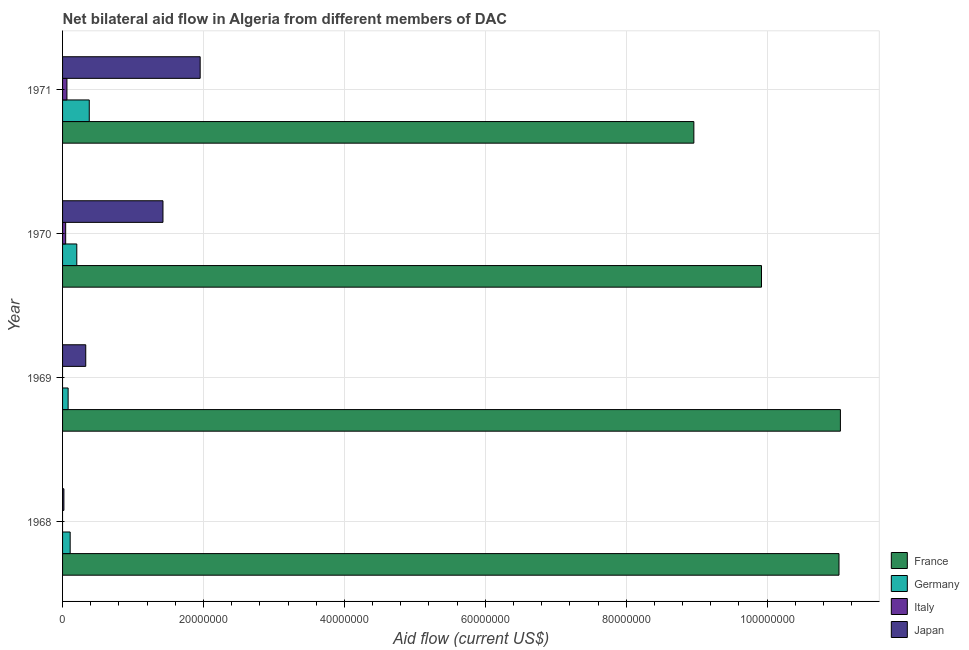How many different coloured bars are there?
Provide a short and direct response. 4. Are the number of bars on each tick of the Y-axis equal?
Offer a very short reply. No. How many bars are there on the 4th tick from the top?
Make the answer very short. 3. How many bars are there on the 1st tick from the bottom?
Provide a short and direct response. 3. What is the label of the 1st group of bars from the top?
Make the answer very short. 1971. In how many cases, is the number of bars for a given year not equal to the number of legend labels?
Provide a short and direct response. 2. What is the amount of aid given by japan in 1969?
Offer a very short reply. 3.29e+06. Across all years, what is the maximum amount of aid given by japan?
Offer a very short reply. 1.95e+07. Across all years, what is the minimum amount of aid given by france?
Provide a short and direct response. 8.96e+07. In which year was the amount of aid given by italy maximum?
Your answer should be compact. 1971. What is the total amount of aid given by germany in the graph?
Provide a short and direct response. 7.68e+06. What is the difference between the amount of aid given by germany in 1969 and that in 1971?
Keep it short and to the point. -3.00e+06. What is the difference between the amount of aid given by italy in 1969 and the amount of aid given by germany in 1971?
Your answer should be very brief. -3.79e+06. What is the average amount of aid given by italy per year?
Offer a very short reply. 2.65e+05. In the year 1971, what is the difference between the amount of aid given by japan and amount of aid given by germany?
Ensure brevity in your answer.  1.57e+07. In how many years, is the amount of aid given by japan greater than 28000000 US$?
Your response must be concise. 0. What is the ratio of the amount of aid given by japan in 1968 to that in 1969?
Your response must be concise. 0.06. Is the difference between the amount of aid given by france in 1970 and 1971 greater than the difference between the amount of aid given by japan in 1970 and 1971?
Make the answer very short. Yes. What is the difference between the highest and the second highest amount of aid given by germany?
Give a very brief answer. 1.77e+06. What is the difference between the highest and the lowest amount of aid given by france?
Offer a terse response. 2.08e+07. In how many years, is the amount of aid given by japan greater than the average amount of aid given by japan taken over all years?
Offer a terse response. 2. Is it the case that in every year, the sum of the amount of aid given by italy and amount of aid given by germany is greater than the sum of amount of aid given by france and amount of aid given by japan?
Provide a short and direct response. No. Are all the bars in the graph horizontal?
Ensure brevity in your answer.  Yes. How many years are there in the graph?
Offer a very short reply. 4. Does the graph contain any zero values?
Your response must be concise. Yes. Where does the legend appear in the graph?
Offer a very short reply. Bottom right. How many legend labels are there?
Your response must be concise. 4. What is the title of the graph?
Provide a short and direct response. Net bilateral aid flow in Algeria from different members of DAC. Does "Insurance services" appear as one of the legend labels in the graph?
Ensure brevity in your answer.  No. What is the label or title of the X-axis?
Offer a terse response. Aid flow (current US$). What is the label or title of the Y-axis?
Ensure brevity in your answer.  Year. What is the Aid flow (current US$) of France in 1968?
Offer a terse response. 1.10e+08. What is the Aid flow (current US$) of Germany in 1968?
Offer a terse response. 1.08e+06. What is the Aid flow (current US$) of France in 1969?
Your response must be concise. 1.10e+08. What is the Aid flow (current US$) of Germany in 1969?
Give a very brief answer. 7.90e+05. What is the Aid flow (current US$) of Japan in 1969?
Give a very brief answer. 3.29e+06. What is the Aid flow (current US$) of France in 1970?
Provide a succinct answer. 9.92e+07. What is the Aid flow (current US$) of Germany in 1970?
Your response must be concise. 2.02e+06. What is the Aid flow (current US$) of Italy in 1970?
Ensure brevity in your answer.  4.40e+05. What is the Aid flow (current US$) in Japan in 1970?
Provide a short and direct response. 1.42e+07. What is the Aid flow (current US$) in France in 1971?
Offer a terse response. 8.96e+07. What is the Aid flow (current US$) of Germany in 1971?
Offer a terse response. 3.79e+06. What is the Aid flow (current US$) of Italy in 1971?
Keep it short and to the point. 6.20e+05. What is the Aid flow (current US$) of Japan in 1971?
Your answer should be very brief. 1.95e+07. Across all years, what is the maximum Aid flow (current US$) in France?
Give a very brief answer. 1.10e+08. Across all years, what is the maximum Aid flow (current US$) in Germany?
Provide a short and direct response. 3.79e+06. Across all years, what is the maximum Aid flow (current US$) in Italy?
Your response must be concise. 6.20e+05. Across all years, what is the maximum Aid flow (current US$) of Japan?
Provide a short and direct response. 1.95e+07. Across all years, what is the minimum Aid flow (current US$) of France?
Give a very brief answer. 8.96e+07. Across all years, what is the minimum Aid flow (current US$) in Germany?
Your response must be concise. 7.90e+05. Across all years, what is the minimum Aid flow (current US$) of Italy?
Ensure brevity in your answer.  0. Across all years, what is the minimum Aid flow (current US$) of Japan?
Offer a terse response. 1.90e+05. What is the total Aid flow (current US$) of France in the graph?
Provide a succinct answer. 4.09e+08. What is the total Aid flow (current US$) in Germany in the graph?
Offer a terse response. 7.68e+06. What is the total Aid flow (current US$) in Italy in the graph?
Your answer should be compact. 1.06e+06. What is the total Aid flow (current US$) of Japan in the graph?
Provide a short and direct response. 3.73e+07. What is the difference between the Aid flow (current US$) in France in 1968 and that in 1969?
Provide a succinct answer. -2.00e+05. What is the difference between the Aid flow (current US$) in Germany in 1968 and that in 1969?
Keep it short and to the point. 2.90e+05. What is the difference between the Aid flow (current US$) in Japan in 1968 and that in 1969?
Provide a succinct answer. -3.10e+06. What is the difference between the Aid flow (current US$) in France in 1968 and that in 1970?
Your answer should be very brief. 1.10e+07. What is the difference between the Aid flow (current US$) in Germany in 1968 and that in 1970?
Provide a succinct answer. -9.40e+05. What is the difference between the Aid flow (current US$) in Japan in 1968 and that in 1970?
Keep it short and to the point. -1.41e+07. What is the difference between the Aid flow (current US$) of France in 1968 and that in 1971?
Your answer should be very brief. 2.06e+07. What is the difference between the Aid flow (current US$) of Germany in 1968 and that in 1971?
Your response must be concise. -2.71e+06. What is the difference between the Aid flow (current US$) of Japan in 1968 and that in 1971?
Your response must be concise. -1.93e+07. What is the difference between the Aid flow (current US$) in France in 1969 and that in 1970?
Your answer should be very brief. 1.12e+07. What is the difference between the Aid flow (current US$) in Germany in 1969 and that in 1970?
Give a very brief answer. -1.23e+06. What is the difference between the Aid flow (current US$) in Japan in 1969 and that in 1970?
Provide a short and direct response. -1.10e+07. What is the difference between the Aid flow (current US$) in France in 1969 and that in 1971?
Provide a short and direct response. 2.08e+07. What is the difference between the Aid flow (current US$) in Germany in 1969 and that in 1971?
Provide a short and direct response. -3.00e+06. What is the difference between the Aid flow (current US$) in Japan in 1969 and that in 1971?
Keep it short and to the point. -1.62e+07. What is the difference between the Aid flow (current US$) of France in 1970 and that in 1971?
Keep it short and to the point. 9.60e+06. What is the difference between the Aid flow (current US$) in Germany in 1970 and that in 1971?
Make the answer very short. -1.77e+06. What is the difference between the Aid flow (current US$) in Japan in 1970 and that in 1971?
Ensure brevity in your answer.  -5.28e+06. What is the difference between the Aid flow (current US$) of France in 1968 and the Aid flow (current US$) of Germany in 1969?
Provide a short and direct response. 1.09e+08. What is the difference between the Aid flow (current US$) of France in 1968 and the Aid flow (current US$) of Japan in 1969?
Provide a short and direct response. 1.07e+08. What is the difference between the Aid flow (current US$) of Germany in 1968 and the Aid flow (current US$) of Japan in 1969?
Keep it short and to the point. -2.21e+06. What is the difference between the Aid flow (current US$) of France in 1968 and the Aid flow (current US$) of Germany in 1970?
Your answer should be very brief. 1.08e+08. What is the difference between the Aid flow (current US$) in France in 1968 and the Aid flow (current US$) in Italy in 1970?
Provide a short and direct response. 1.10e+08. What is the difference between the Aid flow (current US$) in France in 1968 and the Aid flow (current US$) in Japan in 1970?
Offer a very short reply. 9.60e+07. What is the difference between the Aid flow (current US$) of Germany in 1968 and the Aid flow (current US$) of Italy in 1970?
Provide a short and direct response. 6.40e+05. What is the difference between the Aid flow (current US$) of Germany in 1968 and the Aid flow (current US$) of Japan in 1970?
Make the answer very short. -1.32e+07. What is the difference between the Aid flow (current US$) of France in 1968 and the Aid flow (current US$) of Germany in 1971?
Offer a terse response. 1.06e+08. What is the difference between the Aid flow (current US$) in France in 1968 and the Aid flow (current US$) in Italy in 1971?
Offer a terse response. 1.10e+08. What is the difference between the Aid flow (current US$) of France in 1968 and the Aid flow (current US$) of Japan in 1971?
Keep it short and to the point. 9.07e+07. What is the difference between the Aid flow (current US$) in Germany in 1968 and the Aid flow (current US$) in Japan in 1971?
Keep it short and to the point. -1.84e+07. What is the difference between the Aid flow (current US$) in France in 1969 and the Aid flow (current US$) in Germany in 1970?
Ensure brevity in your answer.  1.08e+08. What is the difference between the Aid flow (current US$) of France in 1969 and the Aid flow (current US$) of Italy in 1970?
Provide a succinct answer. 1.10e+08. What is the difference between the Aid flow (current US$) of France in 1969 and the Aid flow (current US$) of Japan in 1970?
Your answer should be very brief. 9.62e+07. What is the difference between the Aid flow (current US$) of Germany in 1969 and the Aid flow (current US$) of Italy in 1970?
Offer a terse response. 3.50e+05. What is the difference between the Aid flow (current US$) of Germany in 1969 and the Aid flow (current US$) of Japan in 1970?
Offer a terse response. -1.35e+07. What is the difference between the Aid flow (current US$) in France in 1969 and the Aid flow (current US$) in Germany in 1971?
Your answer should be compact. 1.07e+08. What is the difference between the Aid flow (current US$) in France in 1969 and the Aid flow (current US$) in Italy in 1971?
Make the answer very short. 1.10e+08. What is the difference between the Aid flow (current US$) of France in 1969 and the Aid flow (current US$) of Japan in 1971?
Your response must be concise. 9.09e+07. What is the difference between the Aid flow (current US$) of Germany in 1969 and the Aid flow (current US$) of Japan in 1971?
Provide a short and direct response. -1.87e+07. What is the difference between the Aid flow (current US$) in France in 1970 and the Aid flow (current US$) in Germany in 1971?
Your response must be concise. 9.54e+07. What is the difference between the Aid flow (current US$) of France in 1970 and the Aid flow (current US$) of Italy in 1971?
Provide a short and direct response. 9.86e+07. What is the difference between the Aid flow (current US$) in France in 1970 and the Aid flow (current US$) in Japan in 1971?
Your answer should be compact. 7.97e+07. What is the difference between the Aid flow (current US$) in Germany in 1970 and the Aid flow (current US$) in Italy in 1971?
Your answer should be very brief. 1.40e+06. What is the difference between the Aid flow (current US$) of Germany in 1970 and the Aid flow (current US$) of Japan in 1971?
Ensure brevity in your answer.  -1.75e+07. What is the difference between the Aid flow (current US$) of Italy in 1970 and the Aid flow (current US$) of Japan in 1971?
Your answer should be compact. -1.91e+07. What is the average Aid flow (current US$) in France per year?
Provide a succinct answer. 1.02e+08. What is the average Aid flow (current US$) of Germany per year?
Ensure brevity in your answer.  1.92e+06. What is the average Aid flow (current US$) in Italy per year?
Give a very brief answer. 2.65e+05. What is the average Aid flow (current US$) in Japan per year?
Your response must be concise. 9.32e+06. In the year 1968, what is the difference between the Aid flow (current US$) in France and Aid flow (current US$) in Germany?
Keep it short and to the point. 1.09e+08. In the year 1968, what is the difference between the Aid flow (current US$) in France and Aid flow (current US$) in Japan?
Ensure brevity in your answer.  1.10e+08. In the year 1968, what is the difference between the Aid flow (current US$) of Germany and Aid flow (current US$) of Japan?
Ensure brevity in your answer.  8.90e+05. In the year 1969, what is the difference between the Aid flow (current US$) in France and Aid flow (current US$) in Germany?
Make the answer very short. 1.10e+08. In the year 1969, what is the difference between the Aid flow (current US$) of France and Aid flow (current US$) of Japan?
Give a very brief answer. 1.07e+08. In the year 1969, what is the difference between the Aid flow (current US$) in Germany and Aid flow (current US$) in Japan?
Give a very brief answer. -2.50e+06. In the year 1970, what is the difference between the Aid flow (current US$) in France and Aid flow (current US$) in Germany?
Ensure brevity in your answer.  9.72e+07. In the year 1970, what is the difference between the Aid flow (current US$) of France and Aid flow (current US$) of Italy?
Ensure brevity in your answer.  9.88e+07. In the year 1970, what is the difference between the Aid flow (current US$) of France and Aid flow (current US$) of Japan?
Ensure brevity in your answer.  8.50e+07. In the year 1970, what is the difference between the Aid flow (current US$) in Germany and Aid flow (current US$) in Italy?
Give a very brief answer. 1.58e+06. In the year 1970, what is the difference between the Aid flow (current US$) of Germany and Aid flow (current US$) of Japan?
Make the answer very short. -1.22e+07. In the year 1970, what is the difference between the Aid flow (current US$) in Italy and Aid flow (current US$) in Japan?
Offer a very short reply. -1.38e+07. In the year 1971, what is the difference between the Aid flow (current US$) of France and Aid flow (current US$) of Germany?
Provide a succinct answer. 8.58e+07. In the year 1971, what is the difference between the Aid flow (current US$) of France and Aid flow (current US$) of Italy?
Your answer should be compact. 8.90e+07. In the year 1971, what is the difference between the Aid flow (current US$) in France and Aid flow (current US$) in Japan?
Ensure brevity in your answer.  7.01e+07. In the year 1971, what is the difference between the Aid flow (current US$) of Germany and Aid flow (current US$) of Italy?
Offer a terse response. 3.17e+06. In the year 1971, what is the difference between the Aid flow (current US$) of Germany and Aid flow (current US$) of Japan?
Provide a short and direct response. -1.57e+07. In the year 1971, what is the difference between the Aid flow (current US$) in Italy and Aid flow (current US$) in Japan?
Offer a terse response. -1.89e+07. What is the ratio of the Aid flow (current US$) of Germany in 1968 to that in 1969?
Your response must be concise. 1.37. What is the ratio of the Aid flow (current US$) of Japan in 1968 to that in 1969?
Keep it short and to the point. 0.06. What is the ratio of the Aid flow (current US$) of France in 1968 to that in 1970?
Give a very brief answer. 1.11. What is the ratio of the Aid flow (current US$) in Germany in 1968 to that in 1970?
Offer a very short reply. 0.53. What is the ratio of the Aid flow (current US$) in Japan in 1968 to that in 1970?
Ensure brevity in your answer.  0.01. What is the ratio of the Aid flow (current US$) of France in 1968 to that in 1971?
Offer a terse response. 1.23. What is the ratio of the Aid flow (current US$) of Germany in 1968 to that in 1971?
Give a very brief answer. 0.28. What is the ratio of the Aid flow (current US$) of Japan in 1968 to that in 1971?
Provide a short and direct response. 0.01. What is the ratio of the Aid flow (current US$) in France in 1969 to that in 1970?
Offer a very short reply. 1.11. What is the ratio of the Aid flow (current US$) of Germany in 1969 to that in 1970?
Offer a very short reply. 0.39. What is the ratio of the Aid flow (current US$) of Japan in 1969 to that in 1970?
Ensure brevity in your answer.  0.23. What is the ratio of the Aid flow (current US$) of France in 1969 to that in 1971?
Keep it short and to the point. 1.23. What is the ratio of the Aid flow (current US$) of Germany in 1969 to that in 1971?
Your response must be concise. 0.21. What is the ratio of the Aid flow (current US$) of Japan in 1969 to that in 1971?
Your answer should be very brief. 0.17. What is the ratio of the Aid flow (current US$) of France in 1970 to that in 1971?
Offer a terse response. 1.11. What is the ratio of the Aid flow (current US$) of Germany in 1970 to that in 1971?
Provide a succinct answer. 0.53. What is the ratio of the Aid flow (current US$) in Italy in 1970 to that in 1971?
Provide a short and direct response. 0.71. What is the ratio of the Aid flow (current US$) in Japan in 1970 to that in 1971?
Your answer should be compact. 0.73. What is the difference between the highest and the second highest Aid flow (current US$) of Germany?
Ensure brevity in your answer.  1.77e+06. What is the difference between the highest and the second highest Aid flow (current US$) in Japan?
Provide a short and direct response. 5.28e+06. What is the difference between the highest and the lowest Aid flow (current US$) of France?
Provide a short and direct response. 2.08e+07. What is the difference between the highest and the lowest Aid flow (current US$) of Germany?
Offer a very short reply. 3.00e+06. What is the difference between the highest and the lowest Aid flow (current US$) in Italy?
Offer a very short reply. 6.20e+05. What is the difference between the highest and the lowest Aid flow (current US$) in Japan?
Provide a succinct answer. 1.93e+07. 